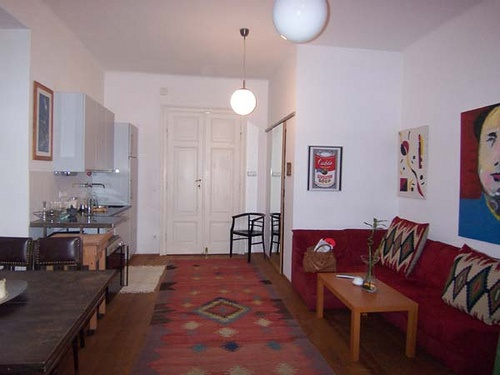Describe the objects in this image and their specific colors. I can see couch in gray, maroon, and black tones, dining table in gray, black, and darkgray tones, refrigerator in gray and darkgray tones, sink in gray and black tones, and chair in gray and black tones in this image. 